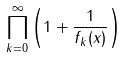Convert formula to latex. <formula><loc_0><loc_0><loc_500><loc_500>\prod _ { k = 0 } ^ { \infty } \left ( 1 + \frac { 1 } { f _ { k } ( x ) } \right )</formula> 